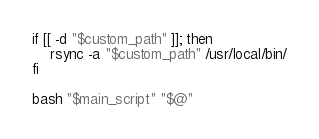<code> <loc_0><loc_0><loc_500><loc_500><_Bash_>if [[ -d "$custom_path" ]]; then
    rsync -a "$custom_path" /usr/local/bin/
fi

bash "$main_script" "$@"
</code> 